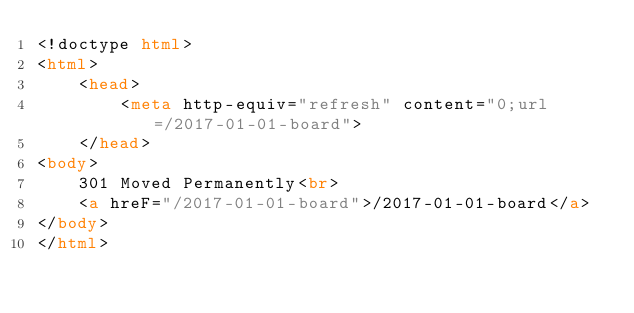Convert code to text. <code><loc_0><loc_0><loc_500><loc_500><_HTML_><!doctype html>
<html>
    <head>
        <meta http-equiv="refresh" content="0;url=/2017-01-01-board">
    </head>
<body>
    301 Moved Permanently<br>
    <a hreF="/2017-01-01-board">/2017-01-01-board</a>
</body>
</html>
</code> 